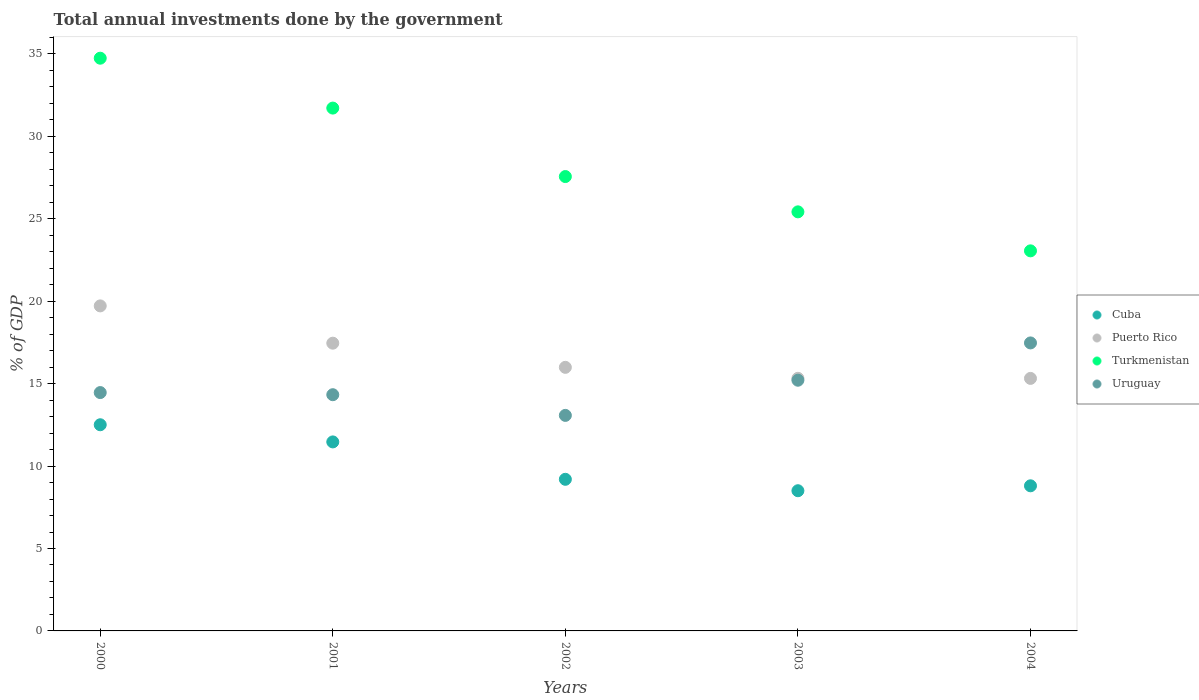Is the number of dotlines equal to the number of legend labels?
Make the answer very short. Yes. What is the total annual investments done by the government in Uruguay in 2002?
Offer a very short reply. 13.07. Across all years, what is the maximum total annual investments done by the government in Cuba?
Give a very brief answer. 12.51. Across all years, what is the minimum total annual investments done by the government in Uruguay?
Provide a short and direct response. 13.07. What is the total total annual investments done by the government in Uruguay in the graph?
Offer a terse response. 74.53. What is the difference between the total annual investments done by the government in Uruguay in 2001 and that in 2003?
Give a very brief answer. -0.88. What is the difference between the total annual investments done by the government in Puerto Rico in 2001 and the total annual investments done by the government in Uruguay in 2000?
Provide a succinct answer. 3. What is the average total annual investments done by the government in Cuba per year?
Keep it short and to the point. 10.09. In the year 2002, what is the difference between the total annual investments done by the government in Cuba and total annual investments done by the government in Puerto Rico?
Offer a very short reply. -6.79. In how many years, is the total annual investments done by the government in Cuba greater than 23 %?
Offer a terse response. 0. What is the ratio of the total annual investments done by the government in Uruguay in 2001 to that in 2002?
Offer a terse response. 1.1. Is the difference between the total annual investments done by the government in Cuba in 2003 and 2004 greater than the difference between the total annual investments done by the government in Puerto Rico in 2003 and 2004?
Provide a succinct answer. No. What is the difference between the highest and the second highest total annual investments done by the government in Puerto Rico?
Make the answer very short. 2.26. What is the difference between the highest and the lowest total annual investments done by the government in Puerto Rico?
Your answer should be compact. 4.4. Is the sum of the total annual investments done by the government in Cuba in 2000 and 2004 greater than the maximum total annual investments done by the government in Uruguay across all years?
Provide a short and direct response. Yes. Is it the case that in every year, the sum of the total annual investments done by the government in Puerto Rico and total annual investments done by the government in Uruguay  is greater than the total annual investments done by the government in Cuba?
Offer a terse response. Yes. How many dotlines are there?
Provide a succinct answer. 4. What is the difference between two consecutive major ticks on the Y-axis?
Your answer should be very brief. 5. Are the values on the major ticks of Y-axis written in scientific E-notation?
Provide a succinct answer. No. Does the graph contain any zero values?
Provide a succinct answer. No. How are the legend labels stacked?
Your answer should be very brief. Vertical. What is the title of the graph?
Ensure brevity in your answer.  Total annual investments done by the government. What is the label or title of the Y-axis?
Offer a very short reply. % of GDP. What is the % of GDP in Cuba in 2000?
Provide a short and direct response. 12.51. What is the % of GDP in Puerto Rico in 2000?
Keep it short and to the point. 19.71. What is the % of GDP of Turkmenistan in 2000?
Offer a very short reply. 34.74. What is the % of GDP in Uruguay in 2000?
Offer a very short reply. 14.46. What is the % of GDP in Cuba in 2001?
Provide a succinct answer. 11.46. What is the % of GDP of Puerto Rico in 2001?
Provide a succinct answer. 17.45. What is the % of GDP in Turkmenistan in 2001?
Give a very brief answer. 31.71. What is the % of GDP in Uruguay in 2001?
Your answer should be compact. 14.33. What is the % of GDP of Cuba in 2002?
Give a very brief answer. 9.2. What is the % of GDP of Puerto Rico in 2002?
Provide a succinct answer. 15.99. What is the % of GDP in Turkmenistan in 2002?
Keep it short and to the point. 27.56. What is the % of GDP of Uruguay in 2002?
Provide a succinct answer. 13.07. What is the % of GDP of Cuba in 2003?
Keep it short and to the point. 8.5. What is the % of GDP of Puerto Rico in 2003?
Keep it short and to the point. 15.32. What is the % of GDP in Turkmenistan in 2003?
Offer a terse response. 25.42. What is the % of GDP of Uruguay in 2003?
Your answer should be very brief. 15.21. What is the % of GDP in Cuba in 2004?
Provide a short and direct response. 8.8. What is the % of GDP of Puerto Rico in 2004?
Your answer should be very brief. 15.32. What is the % of GDP of Turkmenistan in 2004?
Your response must be concise. 23.05. What is the % of GDP in Uruguay in 2004?
Offer a terse response. 17.47. Across all years, what is the maximum % of GDP of Cuba?
Provide a short and direct response. 12.51. Across all years, what is the maximum % of GDP of Puerto Rico?
Provide a short and direct response. 19.71. Across all years, what is the maximum % of GDP in Turkmenistan?
Provide a succinct answer. 34.74. Across all years, what is the maximum % of GDP in Uruguay?
Provide a short and direct response. 17.47. Across all years, what is the minimum % of GDP in Cuba?
Your response must be concise. 8.5. Across all years, what is the minimum % of GDP of Puerto Rico?
Provide a succinct answer. 15.32. Across all years, what is the minimum % of GDP of Turkmenistan?
Provide a short and direct response. 23.05. Across all years, what is the minimum % of GDP of Uruguay?
Give a very brief answer. 13.07. What is the total % of GDP in Cuba in the graph?
Your answer should be compact. 50.47. What is the total % of GDP of Puerto Rico in the graph?
Give a very brief answer. 83.79. What is the total % of GDP of Turkmenistan in the graph?
Make the answer very short. 142.48. What is the total % of GDP in Uruguay in the graph?
Provide a succinct answer. 74.53. What is the difference between the % of GDP in Cuba in 2000 and that in 2001?
Give a very brief answer. 1.04. What is the difference between the % of GDP in Puerto Rico in 2000 and that in 2001?
Your response must be concise. 2.26. What is the difference between the % of GDP in Turkmenistan in 2000 and that in 2001?
Provide a succinct answer. 3.03. What is the difference between the % of GDP of Uruguay in 2000 and that in 2001?
Provide a short and direct response. 0.13. What is the difference between the % of GDP in Cuba in 2000 and that in 2002?
Provide a succinct answer. 3.31. What is the difference between the % of GDP in Puerto Rico in 2000 and that in 2002?
Keep it short and to the point. 3.73. What is the difference between the % of GDP in Turkmenistan in 2000 and that in 2002?
Offer a terse response. 7.18. What is the difference between the % of GDP in Uruguay in 2000 and that in 2002?
Your answer should be compact. 1.38. What is the difference between the % of GDP of Cuba in 2000 and that in 2003?
Provide a succinct answer. 4. What is the difference between the % of GDP of Puerto Rico in 2000 and that in 2003?
Provide a short and direct response. 4.39. What is the difference between the % of GDP in Turkmenistan in 2000 and that in 2003?
Ensure brevity in your answer.  9.32. What is the difference between the % of GDP of Uruguay in 2000 and that in 2003?
Your answer should be compact. -0.75. What is the difference between the % of GDP of Cuba in 2000 and that in 2004?
Provide a short and direct response. 3.7. What is the difference between the % of GDP in Puerto Rico in 2000 and that in 2004?
Offer a terse response. 4.4. What is the difference between the % of GDP in Turkmenistan in 2000 and that in 2004?
Provide a succinct answer. 11.69. What is the difference between the % of GDP in Uruguay in 2000 and that in 2004?
Your answer should be compact. -3.01. What is the difference between the % of GDP of Cuba in 2001 and that in 2002?
Provide a succinct answer. 2.27. What is the difference between the % of GDP of Puerto Rico in 2001 and that in 2002?
Give a very brief answer. 1.47. What is the difference between the % of GDP of Turkmenistan in 2001 and that in 2002?
Your response must be concise. 4.15. What is the difference between the % of GDP of Uruguay in 2001 and that in 2002?
Keep it short and to the point. 1.25. What is the difference between the % of GDP in Cuba in 2001 and that in 2003?
Provide a short and direct response. 2.96. What is the difference between the % of GDP of Puerto Rico in 2001 and that in 2003?
Your answer should be compact. 2.13. What is the difference between the % of GDP of Turkmenistan in 2001 and that in 2003?
Offer a very short reply. 6.29. What is the difference between the % of GDP of Uruguay in 2001 and that in 2003?
Your answer should be compact. -0.88. What is the difference between the % of GDP in Cuba in 2001 and that in 2004?
Offer a terse response. 2.66. What is the difference between the % of GDP in Puerto Rico in 2001 and that in 2004?
Your answer should be very brief. 2.14. What is the difference between the % of GDP in Turkmenistan in 2001 and that in 2004?
Provide a short and direct response. 8.66. What is the difference between the % of GDP of Uruguay in 2001 and that in 2004?
Provide a short and direct response. -3.14. What is the difference between the % of GDP of Cuba in 2002 and that in 2003?
Give a very brief answer. 0.69. What is the difference between the % of GDP of Puerto Rico in 2002 and that in 2003?
Provide a short and direct response. 0.67. What is the difference between the % of GDP in Turkmenistan in 2002 and that in 2003?
Give a very brief answer. 2.14. What is the difference between the % of GDP in Uruguay in 2002 and that in 2003?
Your answer should be very brief. -2.13. What is the difference between the % of GDP in Cuba in 2002 and that in 2004?
Offer a terse response. 0.39. What is the difference between the % of GDP of Puerto Rico in 2002 and that in 2004?
Your answer should be very brief. 0.67. What is the difference between the % of GDP in Turkmenistan in 2002 and that in 2004?
Keep it short and to the point. 4.51. What is the difference between the % of GDP in Uruguay in 2002 and that in 2004?
Provide a succinct answer. -4.4. What is the difference between the % of GDP in Cuba in 2003 and that in 2004?
Keep it short and to the point. -0.3. What is the difference between the % of GDP of Puerto Rico in 2003 and that in 2004?
Keep it short and to the point. 0. What is the difference between the % of GDP of Turkmenistan in 2003 and that in 2004?
Your response must be concise. 2.37. What is the difference between the % of GDP of Uruguay in 2003 and that in 2004?
Provide a succinct answer. -2.26. What is the difference between the % of GDP of Cuba in 2000 and the % of GDP of Puerto Rico in 2001?
Your answer should be compact. -4.95. What is the difference between the % of GDP of Cuba in 2000 and the % of GDP of Turkmenistan in 2001?
Provide a short and direct response. -19.21. What is the difference between the % of GDP of Cuba in 2000 and the % of GDP of Uruguay in 2001?
Your answer should be very brief. -1.82. What is the difference between the % of GDP of Puerto Rico in 2000 and the % of GDP of Turkmenistan in 2001?
Ensure brevity in your answer.  -12. What is the difference between the % of GDP of Puerto Rico in 2000 and the % of GDP of Uruguay in 2001?
Offer a terse response. 5.39. What is the difference between the % of GDP in Turkmenistan in 2000 and the % of GDP in Uruguay in 2001?
Ensure brevity in your answer.  20.41. What is the difference between the % of GDP of Cuba in 2000 and the % of GDP of Puerto Rico in 2002?
Make the answer very short. -3.48. What is the difference between the % of GDP in Cuba in 2000 and the % of GDP in Turkmenistan in 2002?
Offer a very short reply. -15.05. What is the difference between the % of GDP of Cuba in 2000 and the % of GDP of Uruguay in 2002?
Offer a terse response. -0.57. What is the difference between the % of GDP in Puerto Rico in 2000 and the % of GDP in Turkmenistan in 2002?
Your response must be concise. -7.85. What is the difference between the % of GDP in Puerto Rico in 2000 and the % of GDP in Uruguay in 2002?
Provide a short and direct response. 6.64. What is the difference between the % of GDP in Turkmenistan in 2000 and the % of GDP in Uruguay in 2002?
Make the answer very short. 21.67. What is the difference between the % of GDP in Cuba in 2000 and the % of GDP in Puerto Rico in 2003?
Offer a terse response. -2.82. What is the difference between the % of GDP in Cuba in 2000 and the % of GDP in Turkmenistan in 2003?
Your answer should be very brief. -12.91. What is the difference between the % of GDP in Cuba in 2000 and the % of GDP in Uruguay in 2003?
Your answer should be compact. -2.7. What is the difference between the % of GDP of Puerto Rico in 2000 and the % of GDP of Turkmenistan in 2003?
Make the answer very short. -5.7. What is the difference between the % of GDP in Puerto Rico in 2000 and the % of GDP in Uruguay in 2003?
Make the answer very short. 4.51. What is the difference between the % of GDP in Turkmenistan in 2000 and the % of GDP in Uruguay in 2003?
Give a very brief answer. 19.53. What is the difference between the % of GDP in Cuba in 2000 and the % of GDP in Puerto Rico in 2004?
Keep it short and to the point. -2.81. What is the difference between the % of GDP in Cuba in 2000 and the % of GDP in Turkmenistan in 2004?
Provide a short and direct response. -10.55. What is the difference between the % of GDP of Cuba in 2000 and the % of GDP of Uruguay in 2004?
Provide a short and direct response. -4.96. What is the difference between the % of GDP in Puerto Rico in 2000 and the % of GDP in Turkmenistan in 2004?
Your answer should be compact. -3.34. What is the difference between the % of GDP in Puerto Rico in 2000 and the % of GDP in Uruguay in 2004?
Your answer should be very brief. 2.25. What is the difference between the % of GDP in Turkmenistan in 2000 and the % of GDP in Uruguay in 2004?
Your answer should be very brief. 17.27. What is the difference between the % of GDP in Cuba in 2001 and the % of GDP in Puerto Rico in 2002?
Ensure brevity in your answer.  -4.52. What is the difference between the % of GDP of Cuba in 2001 and the % of GDP of Turkmenistan in 2002?
Provide a succinct answer. -16.1. What is the difference between the % of GDP in Cuba in 2001 and the % of GDP in Uruguay in 2002?
Give a very brief answer. -1.61. What is the difference between the % of GDP in Puerto Rico in 2001 and the % of GDP in Turkmenistan in 2002?
Make the answer very short. -10.11. What is the difference between the % of GDP in Puerto Rico in 2001 and the % of GDP in Uruguay in 2002?
Offer a terse response. 4.38. What is the difference between the % of GDP of Turkmenistan in 2001 and the % of GDP of Uruguay in 2002?
Provide a succinct answer. 18.64. What is the difference between the % of GDP in Cuba in 2001 and the % of GDP in Puerto Rico in 2003?
Keep it short and to the point. -3.86. What is the difference between the % of GDP in Cuba in 2001 and the % of GDP in Turkmenistan in 2003?
Your answer should be compact. -13.95. What is the difference between the % of GDP in Cuba in 2001 and the % of GDP in Uruguay in 2003?
Your answer should be very brief. -3.74. What is the difference between the % of GDP in Puerto Rico in 2001 and the % of GDP in Turkmenistan in 2003?
Make the answer very short. -7.97. What is the difference between the % of GDP of Puerto Rico in 2001 and the % of GDP of Uruguay in 2003?
Keep it short and to the point. 2.25. What is the difference between the % of GDP in Turkmenistan in 2001 and the % of GDP in Uruguay in 2003?
Your response must be concise. 16.51. What is the difference between the % of GDP in Cuba in 2001 and the % of GDP in Puerto Rico in 2004?
Provide a short and direct response. -3.85. What is the difference between the % of GDP in Cuba in 2001 and the % of GDP in Turkmenistan in 2004?
Give a very brief answer. -11.59. What is the difference between the % of GDP of Cuba in 2001 and the % of GDP of Uruguay in 2004?
Your answer should be compact. -6. What is the difference between the % of GDP in Puerto Rico in 2001 and the % of GDP in Turkmenistan in 2004?
Your answer should be compact. -5.6. What is the difference between the % of GDP of Puerto Rico in 2001 and the % of GDP of Uruguay in 2004?
Offer a very short reply. -0.02. What is the difference between the % of GDP in Turkmenistan in 2001 and the % of GDP in Uruguay in 2004?
Your response must be concise. 14.24. What is the difference between the % of GDP in Cuba in 2002 and the % of GDP in Puerto Rico in 2003?
Provide a short and direct response. -6.13. What is the difference between the % of GDP in Cuba in 2002 and the % of GDP in Turkmenistan in 2003?
Keep it short and to the point. -16.22. What is the difference between the % of GDP of Cuba in 2002 and the % of GDP of Uruguay in 2003?
Your answer should be very brief. -6.01. What is the difference between the % of GDP of Puerto Rico in 2002 and the % of GDP of Turkmenistan in 2003?
Give a very brief answer. -9.43. What is the difference between the % of GDP of Puerto Rico in 2002 and the % of GDP of Uruguay in 2003?
Your answer should be compact. 0.78. What is the difference between the % of GDP in Turkmenistan in 2002 and the % of GDP in Uruguay in 2003?
Give a very brief answer. 12.35. What is the difference between the % of GDP in Cuba in 2002 and the % of GDP in Puerto Rico in 2004?
Keep it short and to the point. -6.12. What is the difference between the % of GDP of Cuba in 2002 and the % of GDP of Turkmenistan in 2004?
Your response must be concise. -13.86. What is the difference between the % of GDP of Cuba in 2002 and the % of GDP of Uruguay in 2004?
Keep it short and to the point. -8.27. What is the difference between the % of GDP of Puerto Rico in 2002 and the % of GDP of Turkmenistan in 2004?
Your answer should be compact. -7.07. What is the difference between the % of GDP in Puerto Rico in 2002 and the % of GDP in Uruguay in 2004?
Keep it short and to the point. -1.48. What is the difference between the % of GDP in Turkmenistan in 2002 and the % of GDP in Uruguay in 2004?
Provide a short and direct response. 10.09. What is the difference between the % of GDP in Cuba in 2003 and the % of GDP in Puerto Rico in 2004?
Provide a succinct answer. -6.81. What is the difference between the % of GDP in Cuba in 2003 and the % of GDP in Turkmenistan in 2004?
Offer a very short reply. -14.55. What is the difference between the % of GDP of Cuba in 2003 and the % of GDP of Uruguay in 2004?
Ensure brevity in your answer.  -8.96. What is the difference between the % of GDP in Puerto Rico in 2003 and the % of GDP in Turkmenistan in 2004?
Your response must be concise. -7.73. What is the difference between the % of GDP in Puerto Rico in 2003 and the % of GDP in Uruguay in 2004?
Provide a succinct answer. -2.15. What is the difference between the % of GDP in Turkmenistan in 2003 and the % of GDP in Uruguay in 2004?
Your answer should be compact. 7.95. What is the average % of GDP of Cuba per year?
Provide a succinct answer. 10.09. What is the average % of GDP in Puerto Rico per year?
Keep it short and to the point. 16.76. What is the average % of GDP of Turkmenistan per year?
Your answer should be very brief. 28.5. What is the average % of GDP in Uruguay per year?
Ensure brevity in your answer.  14.91. In the year 2000, what is the difference between the % of GDP in Cuba and % of GDP in Puerto Rico?
Your response must be concise. -7.21. In the year 2000, what is the difference between the % of GDP of Cuba and % of GDP of Turkmenistan?
Your answer should be very brief. -22.23. In the year 2000, what is the difference between the % of GDP in Cuba and % of GDP in Uruguay?
Make the answer very short. -1.95. In the year 2000, what is the difference between the % of GDP in Puerto Rico and % of GDP in Turkmenistan?
Your response must be concise. -15.02. In the year 2000, what is the difference between the % of GDP in Puerto Rico and % of GDP in Uruguay?
Make the answer very short. 5.26. In the year 2000, what is the difference between the % of GDP of Turkmenistan and % of GDP of Uruguay?
Your answer should be compact. 20.28. In the year 2001, what is the difference between the % of GDP of Cuba and % of GDP of Puerto Rico?
Give a very brief answer. -5.99. In the year 2001, what is the difference between the % of GDP in Cuba and % of GDP in Turkmenistan?
Provide a short and direct response. -20.25. In the year 2001, what is the difference between the % of GDP of Cuba and % of GDP of Uruguay?
Your answer should be compact. -2.86. In the year 2001, what is the difference between the % of GDP in Puerto Rico and % of GDP in Turkmenistan?
Give a very brief answer. -14.26. In the year 2001, what is the difference between the % of GDP of Puerto Rico and % of GDP of Uruguay?
Provide a succinct answer. 3.13. In the year 2001, what is the difference between the % of GDP of Turkmenistan and % of GDP of Uruguay?
Make the answer very short. 17.38. In the year 2002, what is the difference between the % of GDP of Cuba and % of GDP of Puerto Rico?
Offer a very short reply. -6.79. In the year 2002, what is the difference between the % of GDP of Cuba and % of GDP of Turkmenistan?
Ensure brevity in your answer.  -18.36. In the year 2002, what is the difference between the % of GDP in Cuba and % of GDP in Uruguay?
Keep it short and to the point. -3.88. In the year 2002, what is the difference between the % of GDP of Puerto Rico and % of GDP of Turkmenistan?
Give a very brief answer. -11.57. In the year 2002, what is the difference between the % of GDP of Puerto Rico and % of GDP of Uruguay?
Provide a succinct answer. 2.92. In the year 2002, what is the difference between the % of GDP of Turkmenistan and % of GDP of Uruguay?
Ensure brevity in your answer.  14.49. In the year 2003, what is the difference between the % of GDP of Cuba and % of GDP of Puerto Rico?
Provide a short and direct response. -6.82. In the year 2003, what is the difference between the % of GDP in Cuba and % of GDP in Turkmenistan?
Provide a short and direct response. -16.92. In the year 2003, what is the difference between the % of GDP in Cuba and % of GDP in Uruguay?
Ensure brevity in your answer.  -6.7. In the year 2003, what is the difference between the % of GDP in Puerto Rico and % of GDP in Turkmenistan?
Keep it short and to the point. -10.1. In the year 2003, what is the difference between the % of GDP of Puerto Rico and % of GDP of Uruguay?
Provide a short and direct response. 0.12. In the year 2003, what is the difference between the % of GDP in Turkmenistan and % of GDP in Uruguay?
Provide a short and direct response. 10.21. In the year 2004, what is the difference between the % of GDP of Cuba and % of GDP of Puerto Rico?
Offer a terse response. -6.52. In the year 2004, what is the difference between the % of GDP in Cuba and % of GDP in Turkmenistan?
Ensure brevity in your answer.  -14.25. In the year 2004, what is the difference between the % of GDP in Cuba and % of GDP in Uruguay?
Your answer should be very brief. -8.67. In the year 2004, what is the difference between the % of GDP of Puerto Rico and % of GDP of Turkmenistan?
Your answer should be very brief. -7.74. In the year 2004, what is the difference between the % of GDP of Puerto Rico and % of GDP of Uruguay?
Provide a succinct answer. -2.15. In the year 2004, what is the difference between the % of GDP of Turkmenistan and % of GDP of Uruguay?
Keep it short and to the point. 5.59. What is the ratio of the % of GDP of Cuba in 2000 to that in 2001?
Your answer should be very brief. 1.09. What is the ratio of the % of GDP of Puerto Rico in 2000 to that in 2001?
Your answer should be very brief. 1.13. What is the ratio of the % of GDP of Turkmenistan in 2000 to that in 2001?
Provide a succinct answer. 1.1. What is the ratio of the % of GDP in Uruguay in 2000 to that in 2001?
Give a very brief answer. 1.01. What is the ratio of the % of GDP in Cuba in 2000 to that in 2002?
Give a very brief answer. 1.36. What is the ratio of the % of GDP in Puerto Rico in 2000 to that in 2002?
Your answer should be very brief. 1.23. What is the ratio of the % of GDP in Turkmenistan in 2000 to that in 2002?
Provide a short and direct response. 1.26. What is the ratio of the % of GDP of Uruguay in 2000 to that in 2002?
Ensure brevity in your answer.  1.11. What is the ratio of the % of GDP of Cuba in 2000 to that in 2003?
Offer a terse response. 1.47. What is the ratio of the % of GDP in Puerto Rico in 2000 to that in 2003?
Give a very brief answer. 1.29. What is the ratio of the % of GDP in Turkmenistan in 2000 to that in 2003?
Your answer should be very brief. 1.37. What is the ratio of the % of GDP in Uruguay in 2000 to that in 2003?
Offer a very short reply. 0.95. What is the ratio of the % of GDP in Cuba in 2000 to that in 2004?
Ensure brevity in your answer.  1.42. What is the ratio of the % of GDP of Puerto Rico in 2000 to that in 2004?
Offer a terse response. 1.29. What is the ratio of the % of GDP of Turkmenistan in 2000 to that in 2004?
Offer a terse response. 1.51. What is the ratio of the % of GDP of Uruguay in 2000 to that in 2004?
Your answer should be compact. 0.83. What is the ratio of the % of GDP in Cuba in 2001 to that in 2002?
Offer a terse response. 1.25. What is the ratio of the % of GDP in Puerto Rico in 2001 to that in 2002?
Ensure brevity in your answer.  1.09. What is the ratio of the % of GDP of Turkmenistan in 2001 to that in 2002?
Provide a short and direct response. 1.15. What is the ratio of the % of GDP in Uruguay in 2001 to that in 2002?
Provide a succinct answer. 1.1. What is the ratio of the % of GDP in Cuba in 2001 to that in 2003?
Your answer should be compact. 1.35. What is the ratio of the % of GDP of Puerto Rico in 2001 to that in 2003?
Offer a terse response. 1.14. What is the ratio of the % of GDP of Turkmenistan in 2001 to that in 2003?
Provide a short and direct response. 1.25. What is the ratio of the % of GDP in Uruguay in 2001 to that in 2003?
Give a very brief answer. 0.94. What is the ratio of the % of GDP of Cuba in 2001 to that in 2004?
Keep it short and to the point. 1.3. What is the ratio of the % of GDP in Puerto Rico in 2001 to that in 2004?
Make the answer very short. 1.14. What is the ratio of the % of GDP in Turkmenistan in 2001 to that in 2004?
Your answer should be very brief. 1.38. What is the ratio of the % of GDP of Uruguay in 2001 to that in 2004?
Give a very brief answer. 0.82. What is the ratio of the % of GDP of Cuba in 2002 to that in 2003?
Offer a terse response. 1.08. What is the ratio of the % of GDP of Puerto Rico in 2002 to that in 2003?
Your response must be concise. 1.04. What is the ratio of the % of GDP in Turkmenistan in 2002 to that in 2003?
Give a very brief answer. 1.08. What is the ratio of the % of GDP of Uruguay in 2002 to that in 2003?
Offer a very short reply. 0.86. What is the ratio of the % of GDP of Cuba in 2002 to that in 2004?
Provide a short and direct response. 1.04. What is the ratio of the % of GDP in Puerto Rico in 2002 to that in 2004?
Ensure brevity in your answer.  1.04. What is the ratio of the % of GDP of Turkmenistan in 2002 to that in 2004?
Make the answer very short. 1.2. What is the ratio of the % of GDP in Uruguay in 2002 to that in 2004?
Ensure brevity in your answer.  0.75. What is the ratio of the % of GDP of Cuba in 2003 to that in 2004?
Your answer should be very brief. 0.97. What is the ratio of the % of GDP of Turkmenistan in 2003 to that in 2004?
Your response must be concise. 1.1. What is the ratio of the % of GDP in Uruguay in 2003 to that in 2004?
Offer a terse response. 0.87. What is the difference between the highest and the second highest % of GDP in Cuba?
Provide a short and direct response. 1.04. What is the difference between the highest and the second highest % of GDP of Puerto Rico?
Make the answer very short. 2.26. What is the difference between the highest and the second highest % of GDP of Turkmenistan?
Offer a terse response. 3.03. What is the difference between the highest and the second highest % of GDP of Uruguay?
Your answer should be very brief. 2.26. What is the difference between the highest and the lowest % of GDP of Cuba?
Provide a succinct answer. 4. What is the difference between the highest and the lowest % of GDP of Puerto Rico?
Give a very brief answer. 4.4. What is the difference between the highest and the lowest % of GDP of Turkmenistan?
Offer a very short reply. 11.69. What is the difference between the highest and the lowest % of GDP in Uruguay?
Your answer should be very brief. 4.4. 